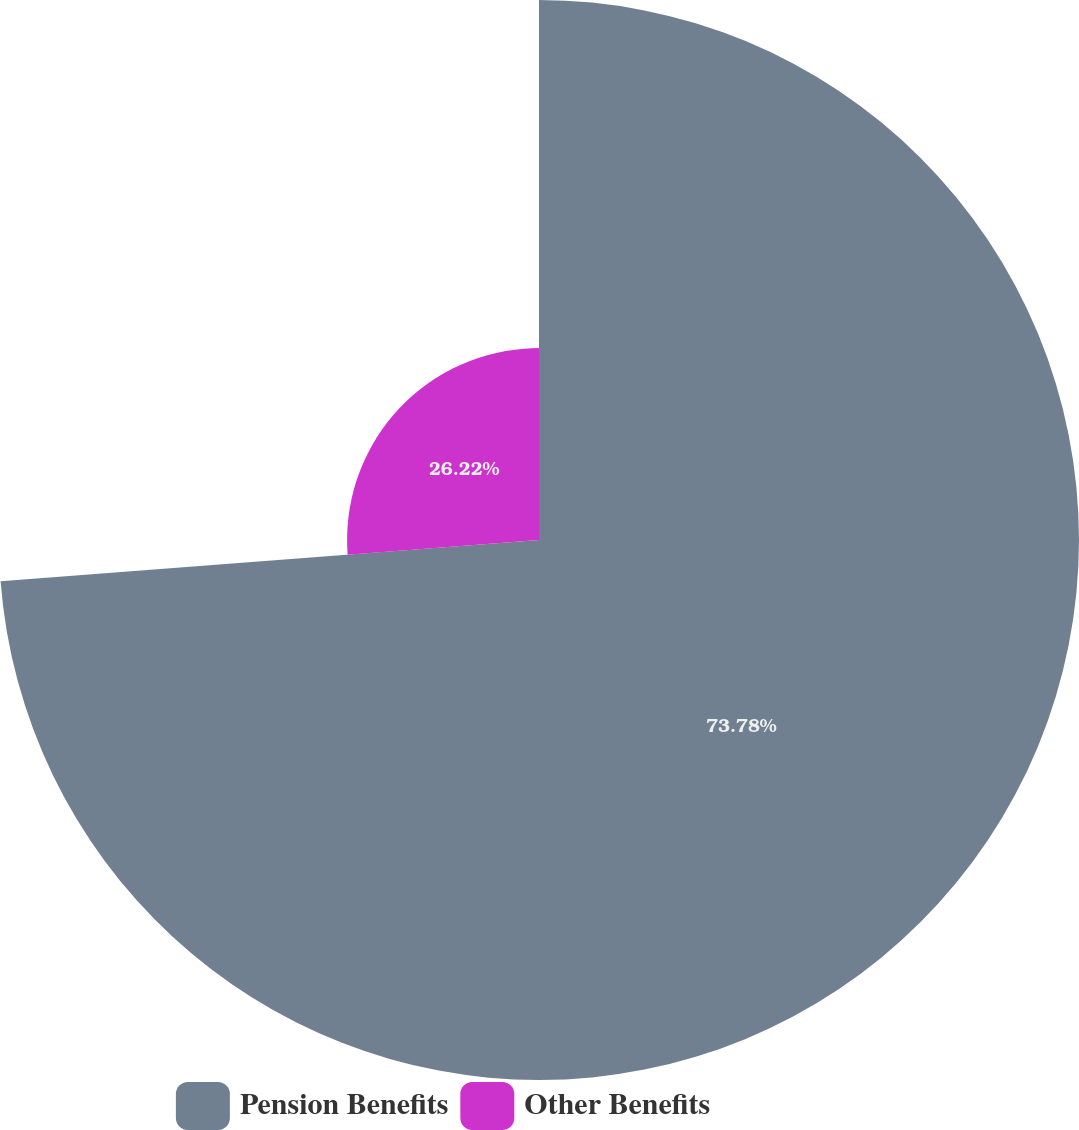Convert chart. <chart><loc_0><loc_0><loc_500><loc_500><pie_chart><fcel>Pension Benefits<fcel>Other Benefits<nl><fcel>73.78%<fcel>26.22%<nl></chart> 